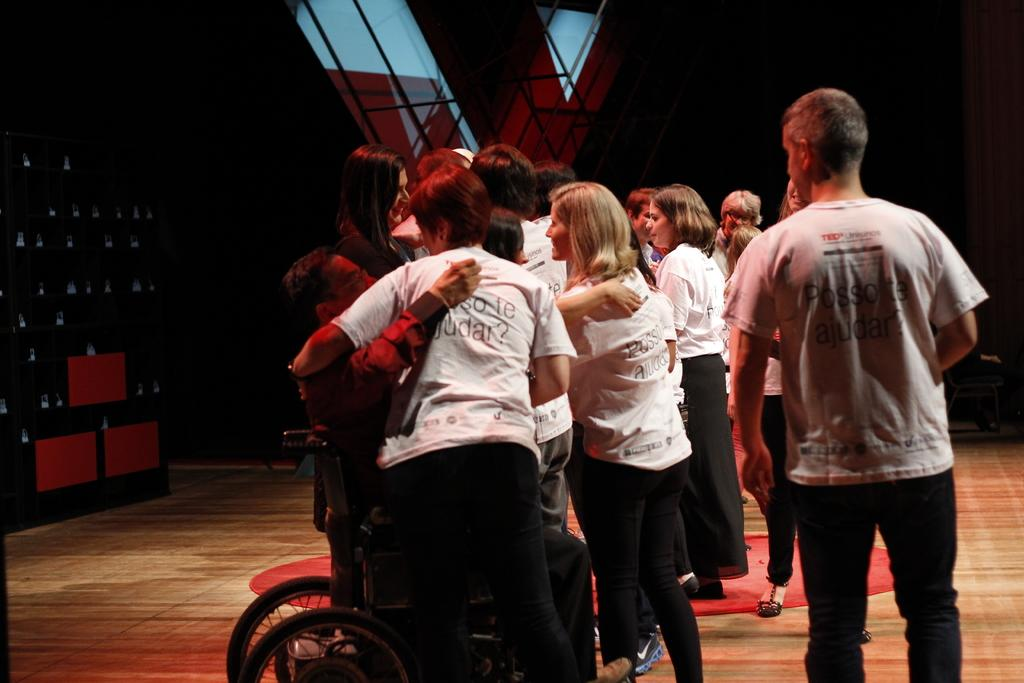How many people are in the image? There is a group of people in the image. What are some of the people in the image doing? Some people are standing. Can you describe the position of one of the individuals in the image? A man is seated in a wheelchair. What color is the ink on the kettle in the image? There is no kettle or ink present in the image. 